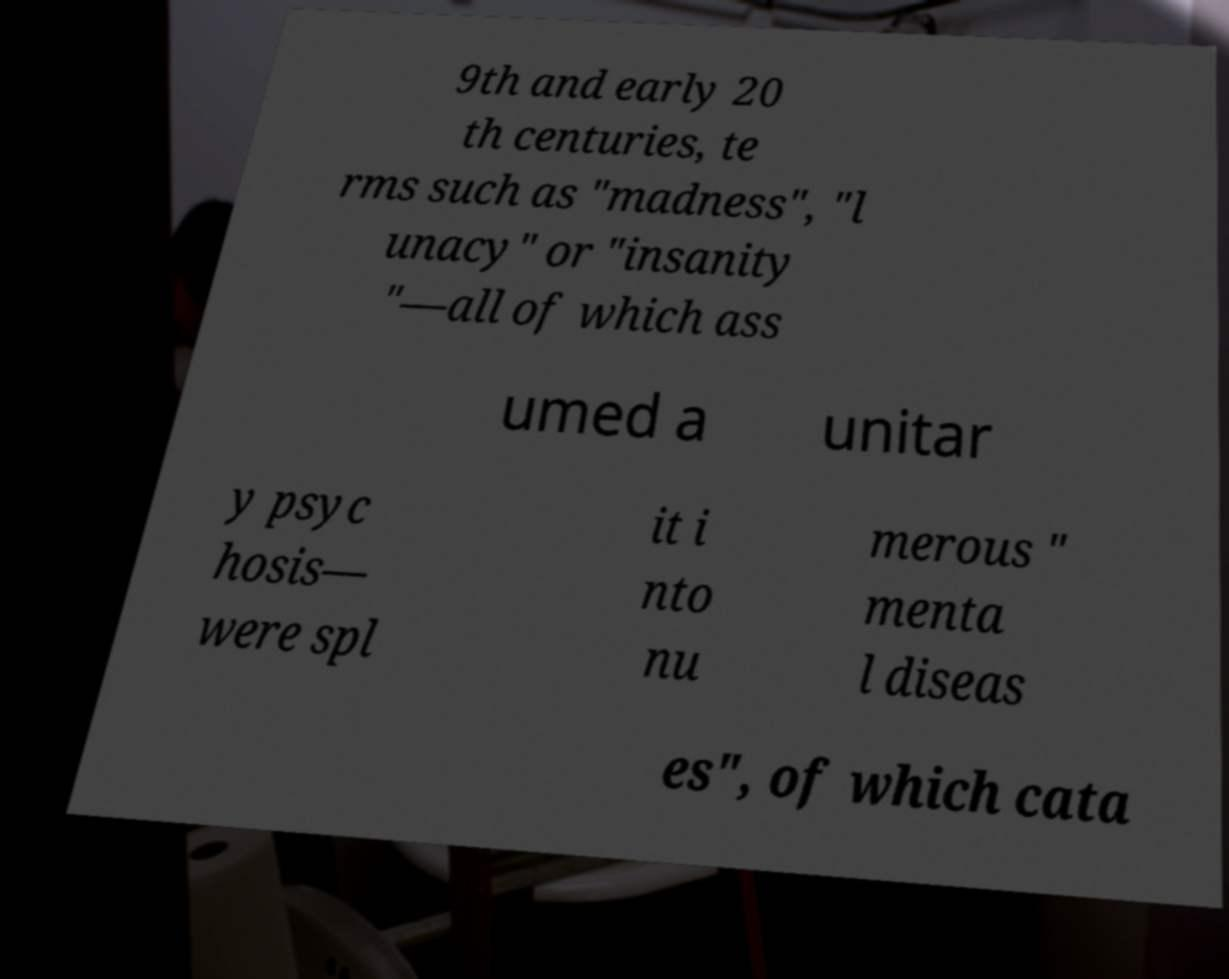Could you assist in decoding the text presented in this image and type it out clearly? 9th and early 20 th centuries, te rms such as "madness", "l unacy" or "insanity "—all of which ass umed a unitar y psyc hosis— were spl it i nto nu merous " menta l diseas es", of which cata 